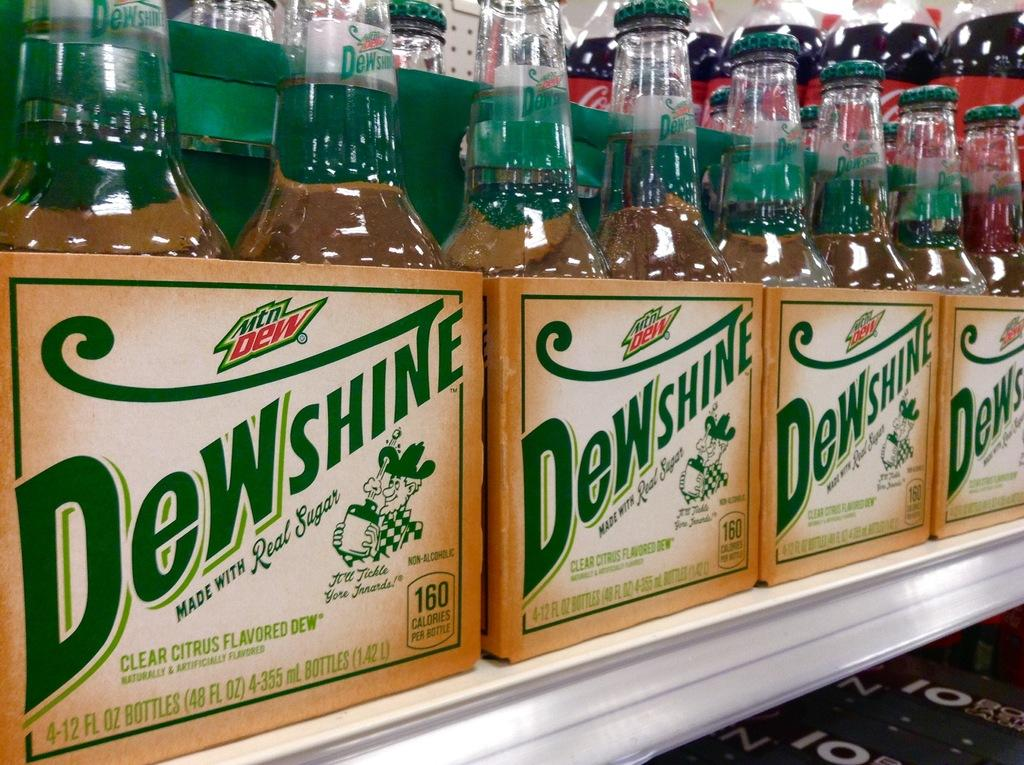<image>
Write a terse but informative summary of the picture. Cases of Dewshine by Mountain Dew are on a shelf. 